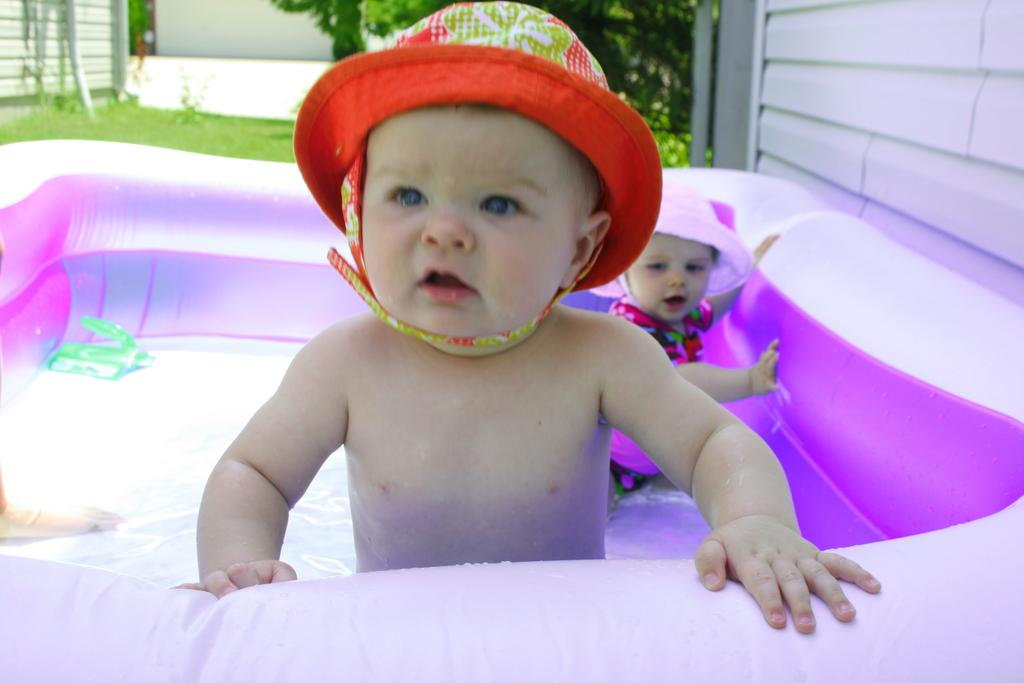What object is present in the image that is filled with water? There is a water balloon in the image. What are the kids doing in the water balloon? The kids are standing in the water balloon. What type of ground surface is visible in the image? There is grass visible in the image. What type of vegetation can be seen in the image? There are trees in the image. What type of structure is visible in the image? There is a wall in the image. What type of frame is visible around the water balloon in the image? There is no frame visible around the water balloon in the image. What feeling can be sensed from the kids in the water balloon? The image does not convey any specific feelings or emotions of the kids; it only shows them standing in the water balloon. 